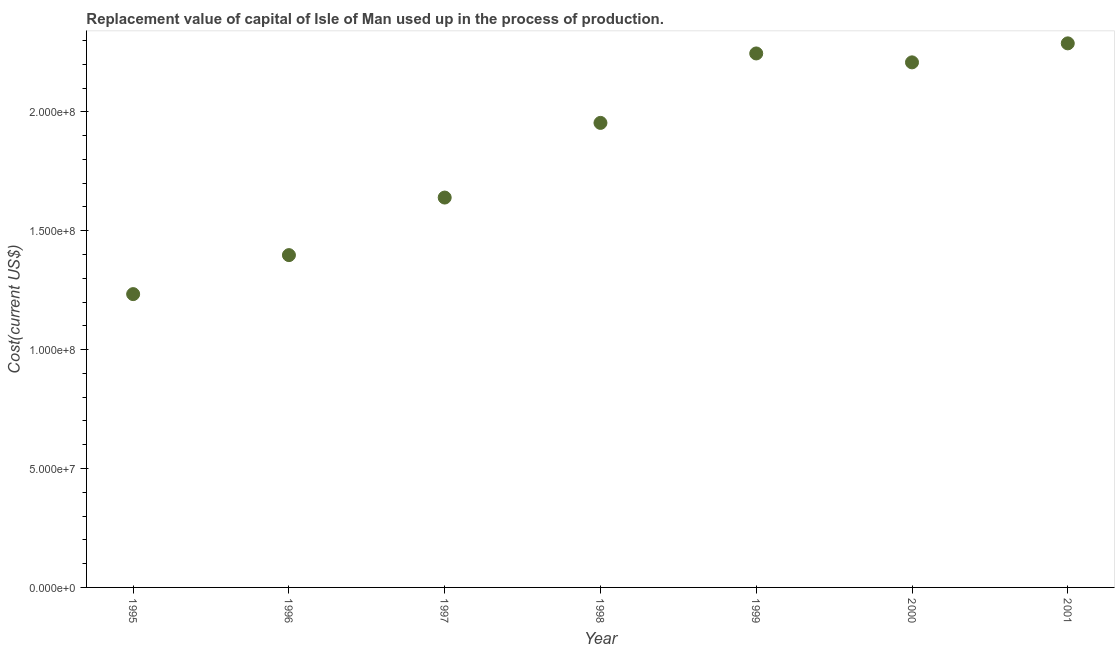What is the consumption of fixed capital in 1996?
Offer a terse response. 1.40e+08. Across all years, what is the maximum consumption of fixed capital?
Keep it short and to the point. 2.29e+08. Across all years, what is the minimum consumption of fixed capital?
Your answer should be compact. 1.23e+08. In which year was the consumption of fixed capital minimum?
Provide a succinct answer. 1995. What is the sum of the consumption of fixed capital?
Make the answer very short. 1.30e+09. What is the difference between the consumption of fixed capital in 1997 and 1999?
Offer a terse response. -6.06e+07. What is the average consumption of fixed capital per year?
Offer a very short reply. 1.85e+08. What is the median consumption of fixed capital?
Provide a succinct answer. 1.95e+08. In how many years, is the consumption of fixed capital greater than 110000000 US$?
Provide a succinct answer. 7. What is the ratio of the consumption of fixed capital in 1995 to that in 2001?
Your answer should be compact. 0.54. Is the consumption of fixed capital in 1996 less than that in 1997?
Provide a short and direct response. Yes. Is the difference between the consumption of fixed capital in 1995 and 1999 greater than the difference between any two years?
Give a very brief answer. No. What is the difference between the highest and the second highest consumption of fixed capital?
Your answer should be very brief. 4.24e+06. What is the difference between the highest and the lowest consumption of fixed capital?
Offer a very short reply. 1.05e+08. In how many years, is the consumption of fixed capital greater than the average consumption of fixed capital taken over all years?
Offer a very short reply. 4. Does the consumption of fixed capital monotonically increase over the years?
Your answer should be compact. No. How many years are there in the graph?
Your answer should be very brief. 7. Are the values on the major ticks of Y-axis written in scientific E-notation?
Your answer should be compact. Yes. Does the graph contain any zero values?
Your answer should be compact. No. Does the graph contain grids?
Offer a very short reply. No. What is the title of the graph?
Offer a very short reply. Replacement value of capital of Isle of Man used up in the process of production. What is the label or title of the Y-axis?
Your answer should be compact. Cost(current US$). What is the Cost(current US$) in 1995?
Ensure brevity in your answer.  1.23e+08. What is the Cost(current US$) in 1996?
Give a very brief answer. 1.40e+08. What is the Cost(current US$) in 1997?
Your answer should be very brief. 1.64e+08. What is the Cost(current US$) in 1998?
Your answer should be compact. 1.95e+08. What is the Cost(current US$) in 1999?
Ensure brevity in your answer.  2.25e+08. What is the Cost(current US$) in 2000?
Make the answer very short. 2.21e+08. What is the Cost(current US$) in 2001?
Your answer should be compact. 2.29e+08. What is the difference between the Cost(current US$) in 1995 and 1996?
Your answer should be very brief. -1.64e+07. What is the difference between the Cost(current US$) in 1995 and 1997?
Give a very brief answer. -4.06e+07. What is the difference between the Cost(current US$) in 1995 and 1998?
Provide a succinct answer. -7.20e+07. What is the difference between the Cost(current US$) in 1995 and 1999?
Provide a succinct answer. -1.01e+08. What is the difference between the Cost(current US$) in 1995 and 2000?
Your answer should be compact. -9.75e+07. What is the difference between the Cost(current US$) in 1995 and 2001?
Your answer should be very brief. -1.05e+08. What is the difference between the Cost(current US$) in 1996 and 1997?
Make the answer very short. -2.42e+07. What is the difference between the Cost(current US$) in 1996 and 1998?
Give a very brief answer. -5.56e+07. What is the difference between the Cost(current US$) in 1996 and 1999?
Offer a very short reply. -8.48e+07. What is the difference between the Cost(current US$) in 1996 and 2000?
Provide a short and direct response. -8.11e+07. What is the difference between the Cost(current US$) in 1996 and 2001?
Offer a terse response. -8.90e+07. What is the difference between the Cost(current US$) in 1997 and 1998?
Make the answer very short. -3.14e+07. What is the difference between the Cost(current US$) in 1997 and 1999?
Offer a very short reply. -6.06e+07. What is the difference between the Cost(current US$) in 1997 and 2000?
Provide a succinct answer. -5.69e+07. What is the difference between the Cost(current US$) in 1997 and 2001?
Give a very brief answer. -6.48e+07. What is the difference between the Cost(current US$) in 1998 and 1999?
Make the answer very short. -2.92e+07. What is the difference between the Cost(current US$) in 1998 and 2000?
Your answer should be compact. -2.55e+07. What is the difference between the Cost(current US$) in 1998 and 2001?
Give a very brief answer. -3.34e+07. What is the difference between the Cost(current US$) in 1999 and 2000?
Keep it short and to the point. 3.75e+06. What is the difference between the Cost(current US$) in 1999 and 2001?
Ensure brevity in your answer.  -4.24e+06. What is the difference between the Cost(current US$) in 2000 and 2001?
Offer a very short reply. -7.99e+06. What is the ratio of the Cost(current US$) in 1995 to that in 1996?
Your response must be concise. 0.88. What is the ratio of the Cost(current US$) in 1995 to that in 1997?
Your answer should be compact. 0.75. What is the ratio of the Cost(current US$) in 1995 to that in 1998?
Provide a succinct answer. 0.63. What is the ratio of the Cost(current US$) in 1995 to that in 1999?
Your answer should be compact. 0.55. What is the ratio of the Cost(current US$) in 1995 to that in 2000?
Offer a very short reply. 0.56. What is the ratio of the Cost(current US$) in 1995 to that in 2001?
Offer a very short reply. 0.54. What is the ratio of the Cost(current US$) in 1996 to that in 1997?
Your answer should be compact. 0.85. What is the ratio of the Cost(current US$) in 1996 to that in 1998?
Keep it short and to the point. 0.71. What is the ratio of the Cost(current US$) in 1996 to that in 1999?
Make the answer very short. 0.62. What is the ratio of the Cost(current US$) in 1996 to that in 2000?
Keep it short and to the point. 0.63. What is the ratio of the Cost(current US$) in 1996 to that in 2001?
Ensure brevity in your answer.  0.61. What is the ratio of the Cost(current US$) in 1997 to that in 1998?
Provide a short and direct response. 0.84. What is the ratio of the Cost(current US$) in 1997 to that in 1999?
Provide a short and direct response. 0.73. What is the ratio of the Cost(current US$) in 1997 to that in 2000?
Make the answer very short. 0.74. What is the ratio of the Cost(current US$) in 1997 to that in 2001?
Give a very brief answer. 0.72. What is the ratio of the Cost(current US$) in 1998 to that in 1999?
Your answer should be very brief. 0.87. What is the ratio of the Cost(current US$) in 1998 to that in 2000?
Your response must be concise. 0.89. What is the ratio of the Cost(current US$) in 1998 to that in 2001?
Keep it short and to the point. 0.85. What is the ratio of the Cost(current US$) in 1999 to that in 2000?
Provide a succinct answer. 1.02. 